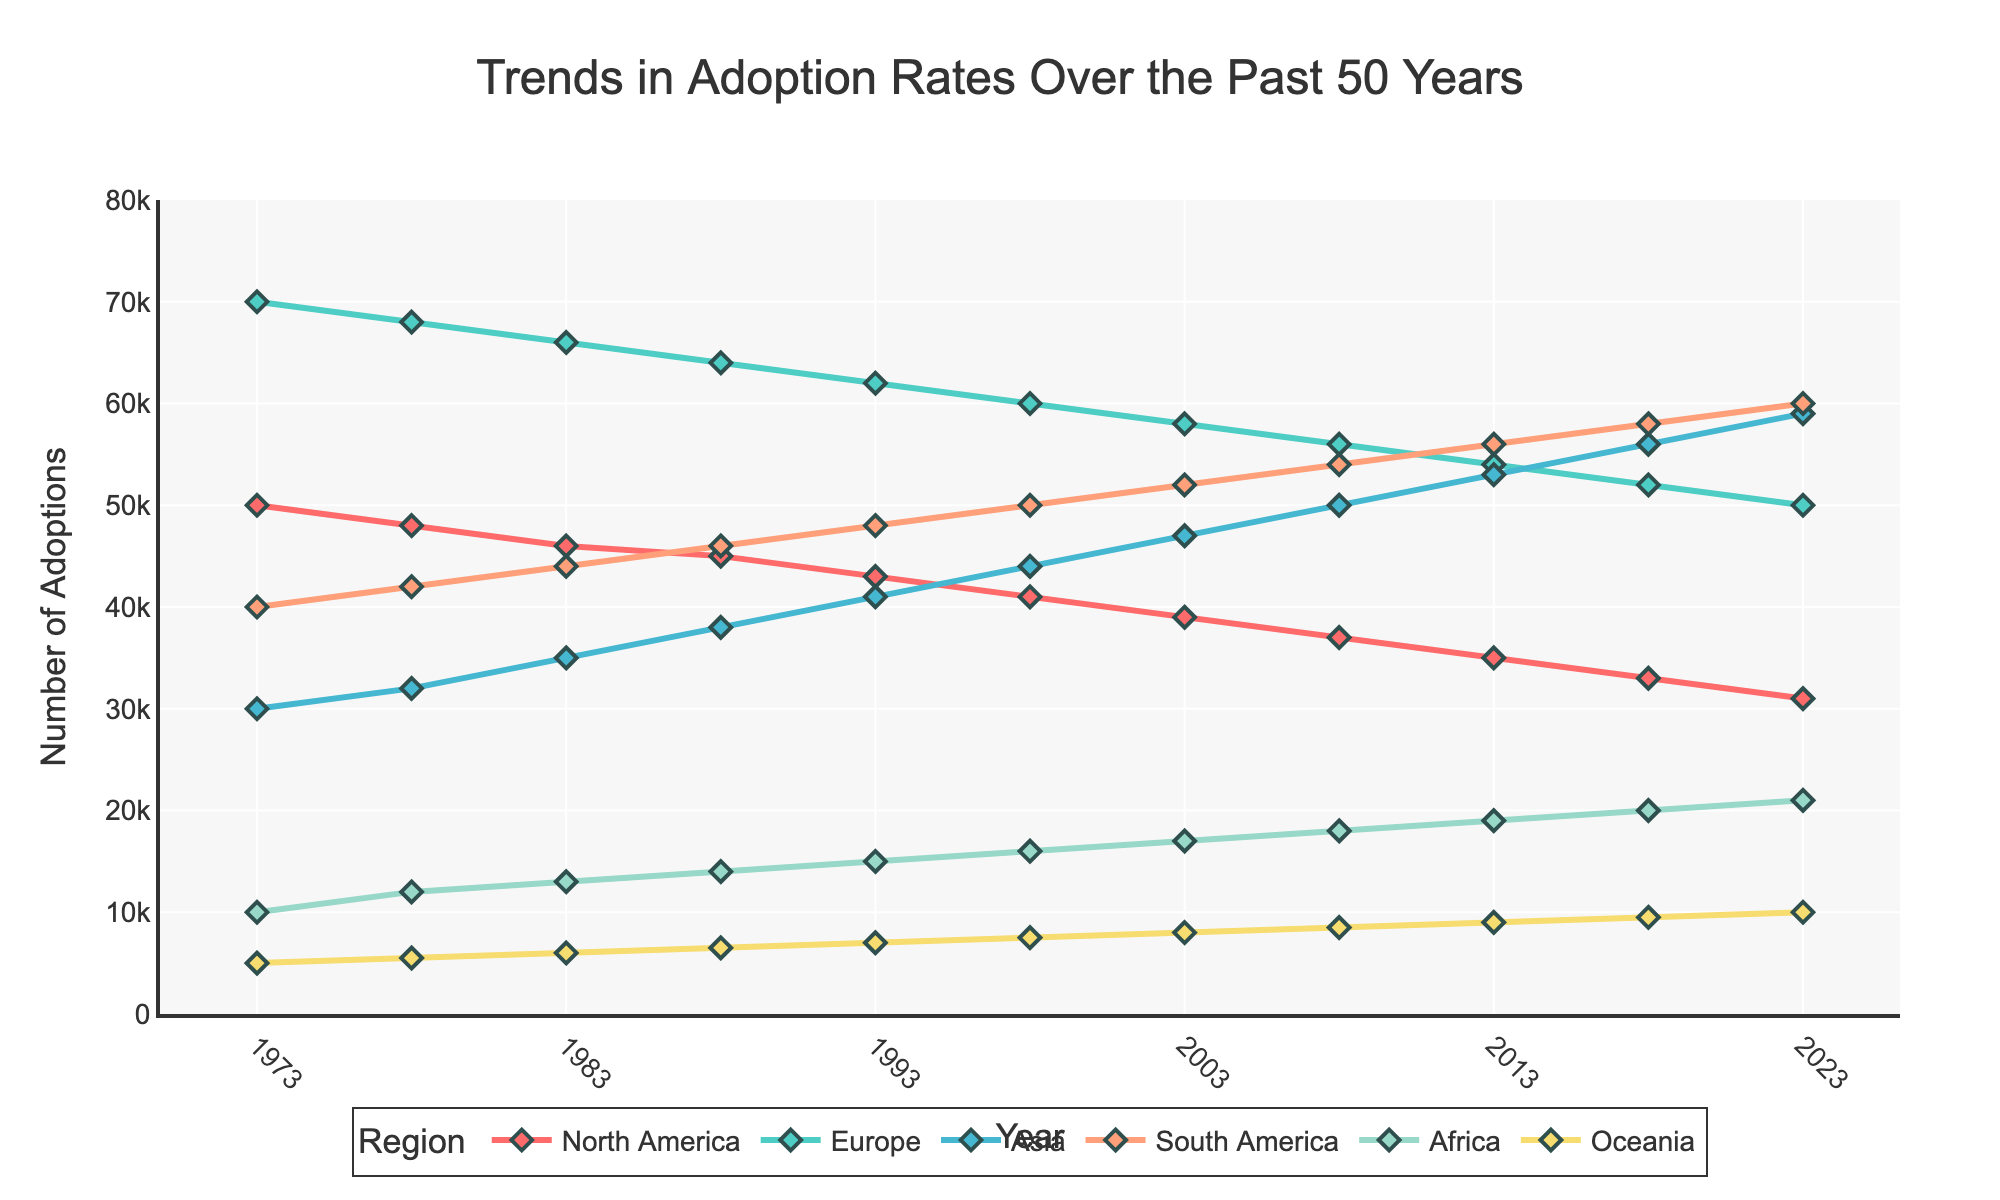What regions are compared in the figure? The plot compares adoption rates over the past 50 years, and the regions listed in the figure are North America, Europe, Asia, South America, Africa, and Oceania.
Answer: North America, Europe, Asia, South America, Africa, Oceania What is the title of the figure? The title is prominently displayed at the top of the figure and reads "Trends in Adoption Rates Over the Past 50 Years."
Answer: Trends in Adoption Rates Over the Past 50 Years Which region has experienced the highest increase in adoption rates from 1973 to 2023? By inspecting the plot lines from 1973 to 2023, we see that Asia's adoption rate increased from 30,000 in 1973 to 59,000 in 2023, indicating the highest increase among the regions.
Answer: Asia How many years are displayed on the x-axis, and what is the interval between the ticks? The x-axis displays years from 1973 to 2023, and there are ticks every 10 years.
Answer: 11 years, 10-year intervals Which region has the lowest adoption rate in 2023, and what is the value? By looking at the data points for 2023, Oceania has the lowest adoption rate with a value of 10,000.
Answer: Oceania, 10,000 What is the average adoption rate in South America over the five selected intervals (1973, 1983, 1993, 2003, 2013)? The values for South America's adoption rates in these intervals are 40,000, 44,000, 48,000, 52,000, and 56,000. Summing these values gives 240,000, and the average is 240,000 / 5.
Answer: 48,000 Is there any region where adoption rates have consistently decreased over the years? By inspecting each region's line graph, North America is the only region where adoption rates have consistently decreased from 50,000 in 1973 to 31,000 in 2023.
Answer: North America Which regions showed an increase in adoption rates from 2008 to 2023? Asia, South America, and Africa showed increases in adoption rates, as evidenced by the upward trend in their lines between 2008 and 2023.
Answer: Asia, South America, Africa How do the adoption rates in Europe compare to those in South America in 1973 and 2023? In 1973, Europe had 70,000 adoptions while South America had 40,000; in 2023, Europe had 50,000 adoptions compared to South America's 60,000. So, Europe started higher but ended lower than South America.
Answer: 1973: Europe > South America, 2023: Europe < South America 